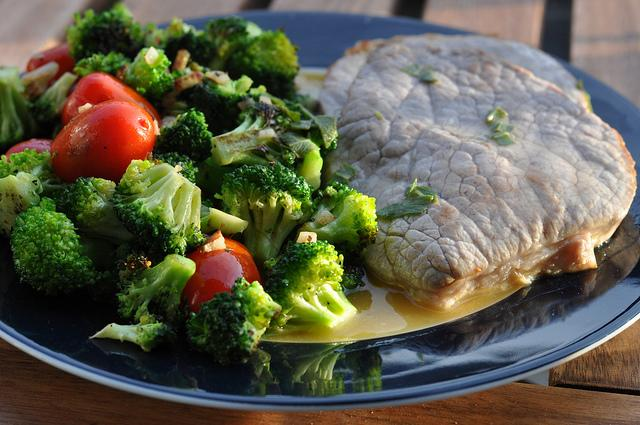What variety of tomato is on the plate? Please explain your reasoning. cherry. These are smaller tomatoes. 